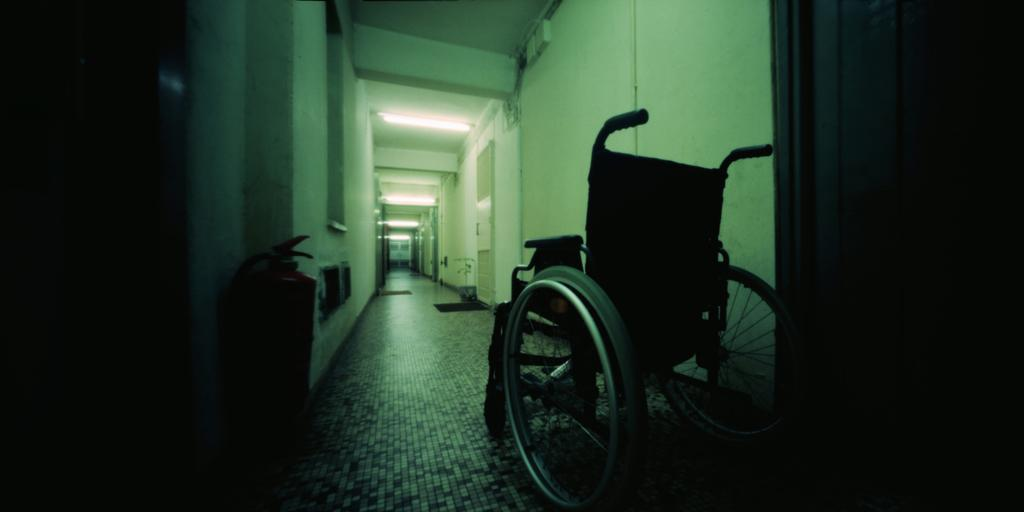What type of location is depicted in the image? The image shows an inside view of a building. Can you describe any specific objects or features in the image? Yes, there is a wheelchair in the bottom left of the image, and there are lights in the middle of the image. What type of ear is visible on the wall in the image? There is no ear visible on the wall in the image. Can you describe the cake that is being served in the image? There is no cake present in the image. 